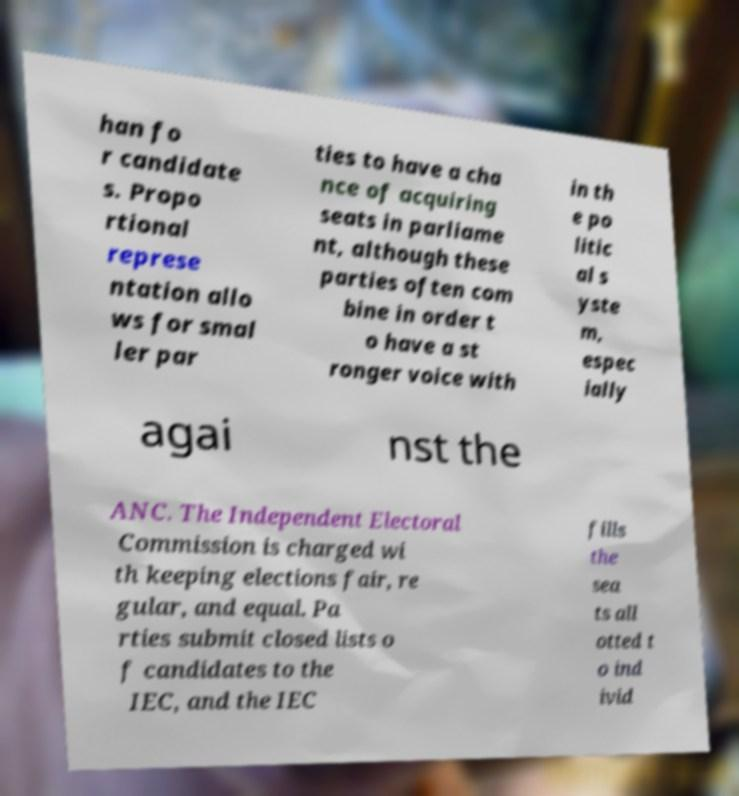Could you extract and type out the text from this image? han fo r candidate s. Propo rtional represe ntation allo ws for smal ler par ties to have a cha nce of acquiring seats in parliame nt, although these parties often com bine in order t o have a st ronger voice with in th e po litic al s yste m, espec ially agai nst the ANC. The Independent Electoral Commission is charged wi th keeping elections fair, re gular, and equal. Pa rties submit closed lists o f candidates to the IEC, and the IEC fills the sea ts all otted t o ind ivid 